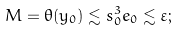<formula> <loc_0><loc_0><loc_500><loc_500>M = \theta ( y _ { 0 } ) \lesssim s _ { 0 } ^ { 3 } e _ { 0 } \lesssim \varepsilon ;</formula> 